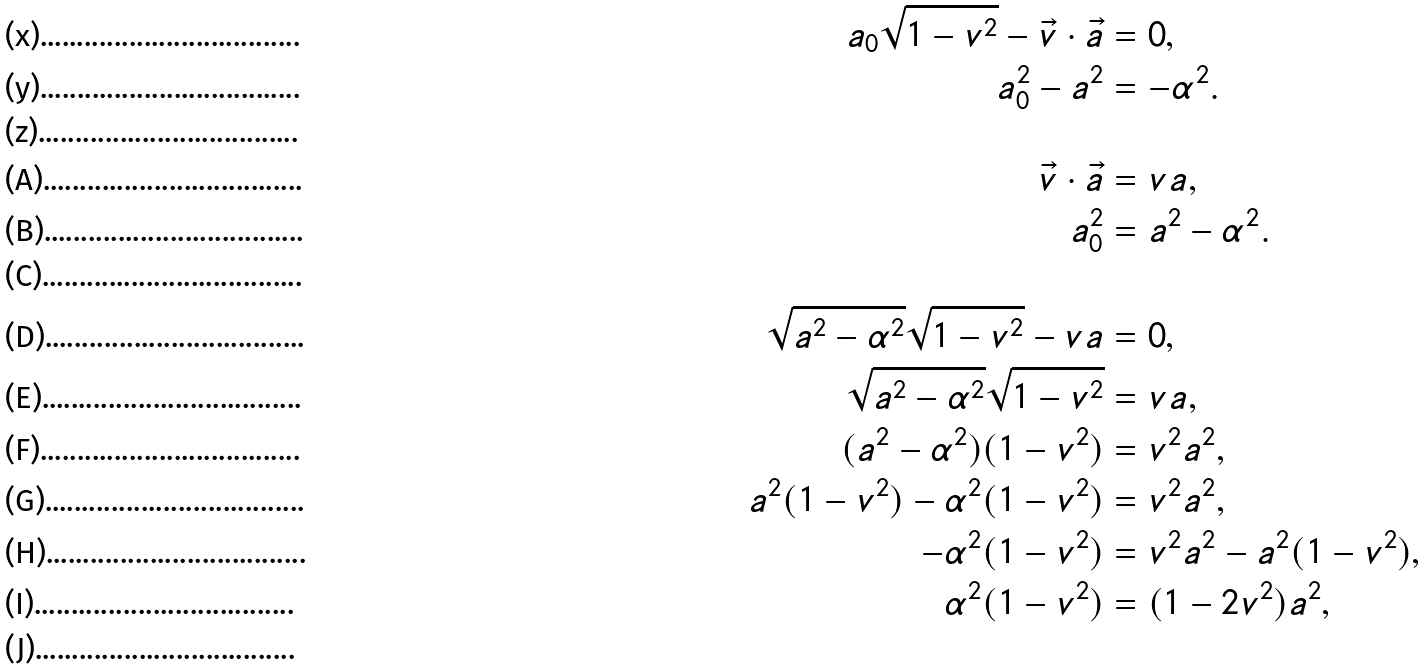Convert formula to latex. <formula><loc_0><loc_0><loc_500><loc_500>a _ { 0 } \sqrt { 1 - v ^ { 2 } } - \vec { v } \cdot \vec { a } & = 0 , \\ a _ { 0 } ^ { 2 } - a ^ { 2 } & = - \alpha ^ { 2 } . \\ & \\ \vec { v } \cdot \vec { a } & = v a , \\ a _ { 0 } ^ { 2 } & = a ^ { 2 } - \alpha ^ { 2 } . \\ & \\ \sqrt { a ^ { 2 } - \alpha ^ { 2 } } \sqrt { 1 - v ^ { 2 } } - v a & = 0 , \\ \sqrt { a ^ { 2 } - \alpha ^ { 2 } } \sqrt { 1 - v ^ { 2 } } & = v a , \\ ( a ^ { 2 } - \alpha ^ { 2 } ) ( 1 - v ^ { 2 } ) & = v ^ { 2 } a ^ { 2 } , \\ a ^ { 2 } ( 1 - v ^ { 2 } ) - \alpha ^ { 2 } ( 1 - v ^ { 2 } ) & = v ^ { 2 } a ^ { 2 } , \\ - \alpha ^ { 2 } ( 1 - v ^ { 2 } ) & = v ^ { 2 } a ^ { 2 } - a ^ { 2 } ( 1 - v ^ { 2 } ) , \\ \alpha ^ { 2 } ( 1 - v ^ { 2 } ) & = ( 1 - 2 v ^ { 2 } ) a ^ { 2 } , \\</formula> 